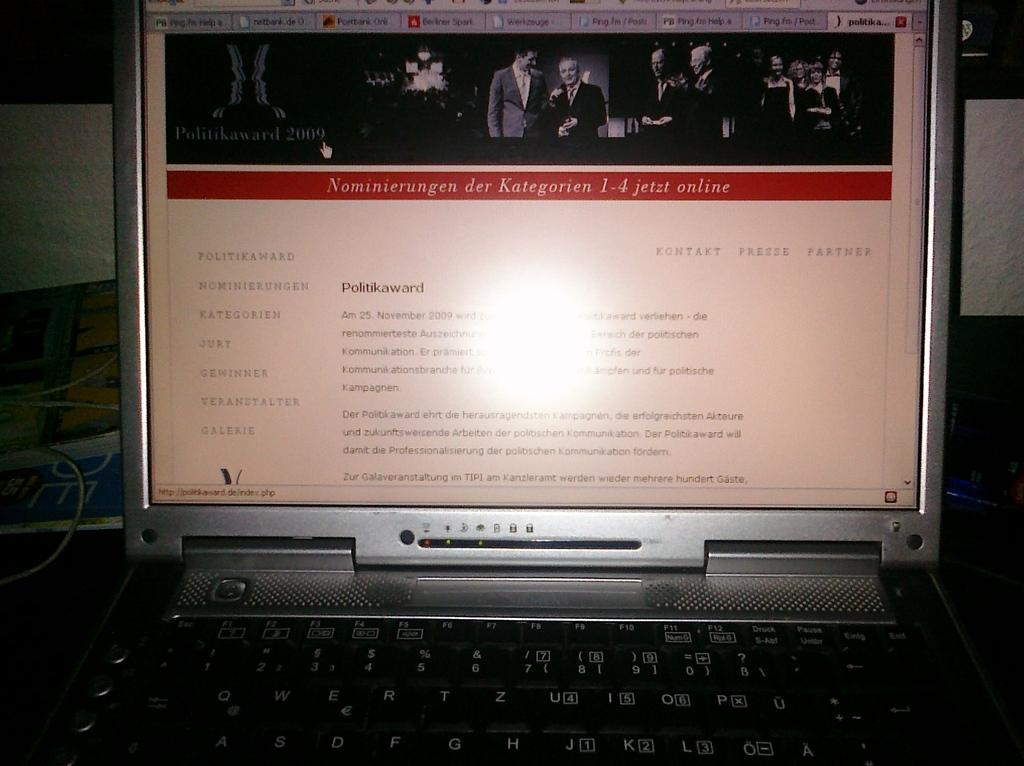<image>
Summarize the visual content of the image. A computer monitor shows, in german, details for the Politikaward Nominierungen. 